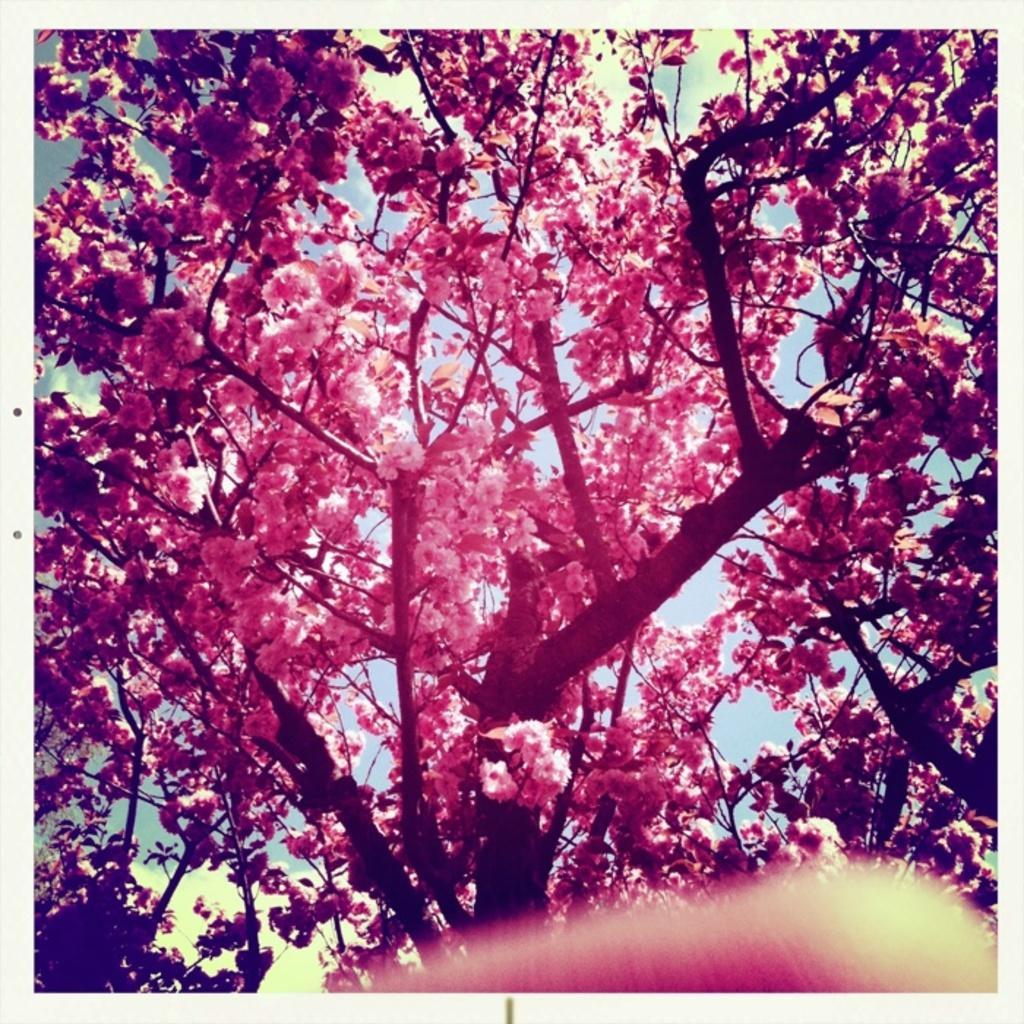In one or two sentences, can you explain what this image depicts? In this image we can see trees with flowers and at the bottom there is an object. In the background we can see clouds in the sky. 